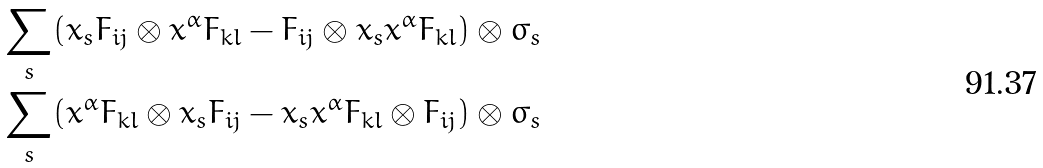Convert formula to latex. <formula><loc_0><loc_0><loc_500><loc_500>& \sum _ { s } ( x _ { s } F _ { i j } \otimes x ^ { \alpha } F _ { k l } - F _ { i j } \otimes x _ { s } x ^ { \alpha } F _ { k l } ) \otimes \varsigma _ { s } \\ & \sum _ { s } ( x ^ { \alpha } F _ { k l } \otimes x _ { s } F _ { i j } - x _ { s } x ^ { \alpha } F _ { k l } \otimes F _ { i j } ) \otimes \varsigma _ { s }</formula> 